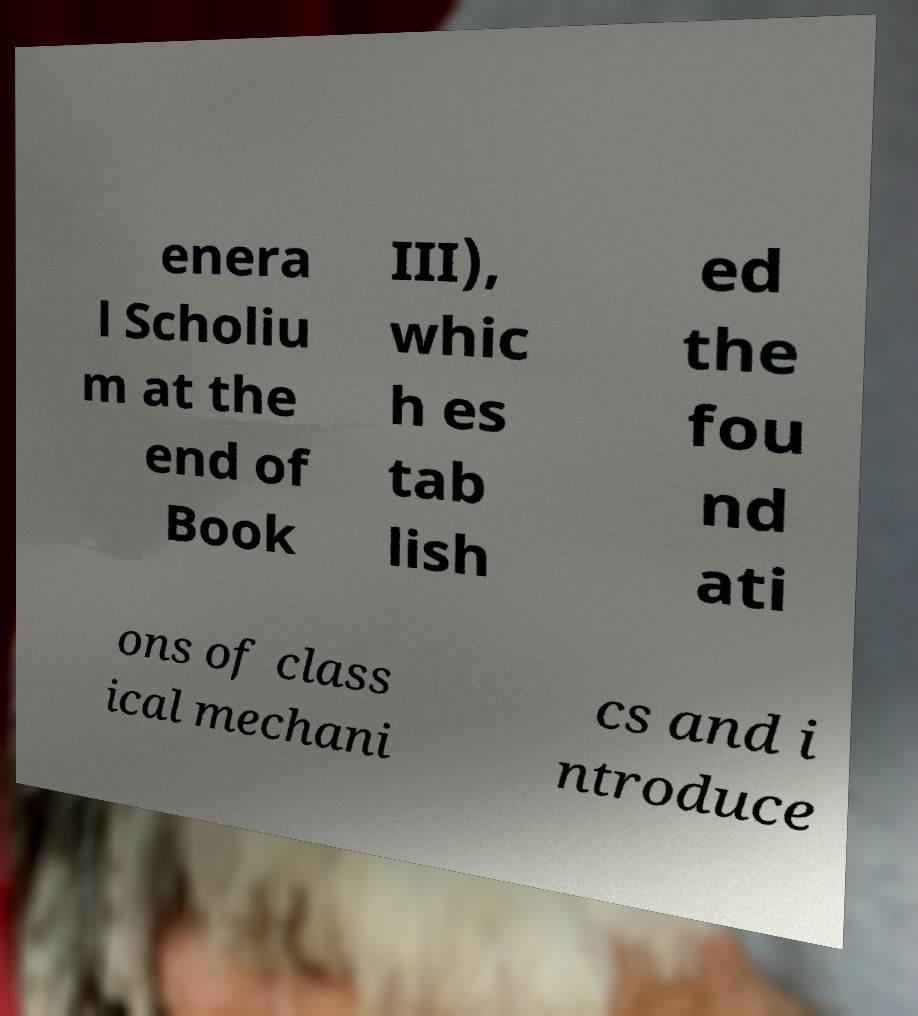Can you accurately transcribe the text from the provided image for me? enera l Scholiu m at the end of Book III), whic h es tab lish ed the fou nd ati ons of class ical mechani cs and i ntroduce 